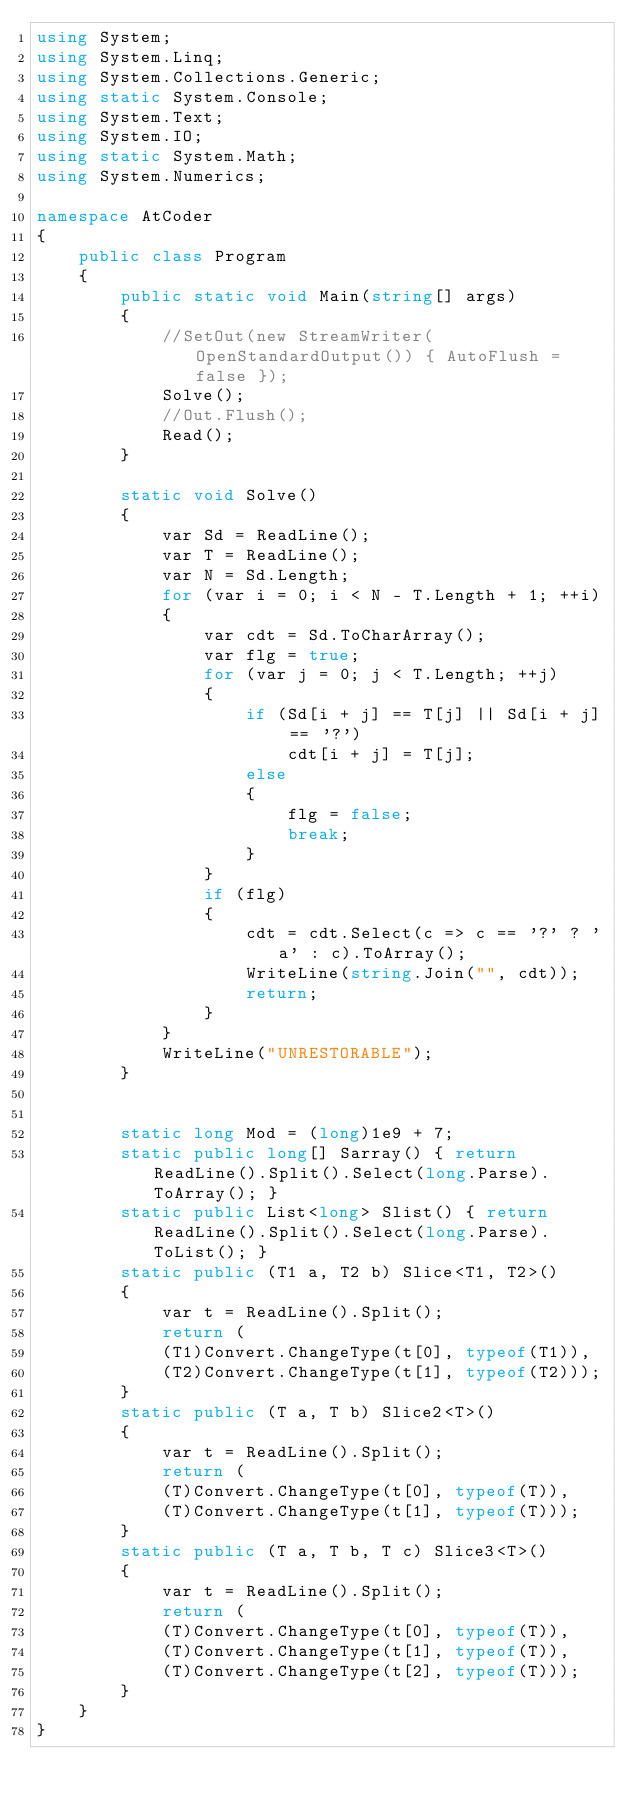Convert code to text. <code><loc_0><loc_0><loc_500><loc_500><_C#_>using System;
using System.Linq;
using System.Collections.Generic;
using static System.Console;
using System.Text;
using System.IO;
using static System.Math;
using System.Numerics;

namespace AtCoder
{
    public class Program
    {
        public static void Main(string[] args)
        {
            //SetOut(new StreamWriter(OpenStandardOutput()) { AutoFlush = false });
            Solve();
            //Out.Flush();
            Read();
        }

        static void Solve()
        {
            var Sd = ReadLine();
            var T = ReadLine();
            var N = Sd.Length;
            for (var i = 0; i < N - T.Length + 1; ++i)
            {
                var cdt = Sd.ToCharArray();
                var flg = true;
                for (var j = 0; j < T.Length; ++j)
                {
                    if (Sd[i + j] == T[j] || Sd[i + j] == '?')
                        cdt[i + j] = T[j];
                    else
                    {
                        flg = false;
                        break;
                    }
                }
                if (flg)
                {
                    cdt = cdt.Select(c => c == '?' ? 'a' : c).ToArray();
                    WriteLine(string.Join("", cdt));
                    return;
                }
            }
            WriteLine("UNRESTORABLE");
        }


        static long Mod = (long)1e9 + 7;
        static public long[] Sarray() { return ReadLine().Split().Select(long.Parse).ToArray(); }
        static public List<long> Slist() { return ReadLine().Split().Select(long.Parse).ToList(); }
        static public (T1 a, T2 b) Slice<T1, T2>()
        {
            var t = ReadLine().Split();
            return (
            (T1)Convert.ChangeType(t[0], typeof(T1)),
            (T2)Convert.ChangeType(t[1], typeof(T2)));
        }
        static public (T a, T b) Slice2<T>()
        {
            var t = ReadLine().Split();
            return (
            (T)Convert.ChangeType(t[0], typeof(T)),
            (T)Convert.ChangeType(t[1], typeof(T)));
        }
        static public (T a, T b, T c) Slice3<T>()
        {
            var t = ReadLine().Split();
            return (
            (T)Convert.ChangeType(t[0], typeof(T)),
            (T)Convert.ChangeType(t[1], typeof(T)),
            (T)Convert.ChangeType(t[2], typeof(T)));
        }
    }
}</code> 